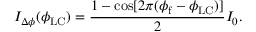<formula> <loc_0><loc_0><loc_500><loc_500>I _ { \Delta \phi } ( \phi _ { L C } ) = \frac { 1 - \cos [ 2 \pi ( \phi _ { f } - \phi _ { L C } ) ] } { 2 } I _ { 0 } .</formula> 